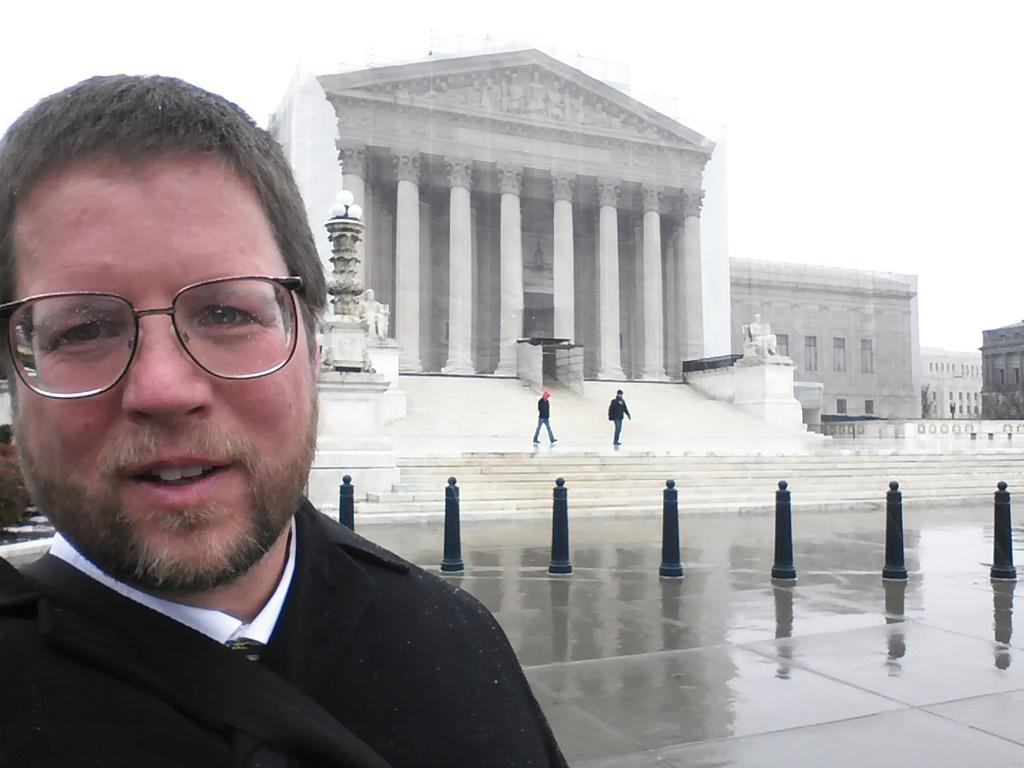What is the person in the image doing? The person is standing on the road. What can be seen on the road in the image? Barrier poles are present in the image. Where are the other persons located in the image? They are standing on a staircase. What type of lighting is visible in the image? Street lights are visible in the image. What type of artwork is present in the image? There are statues in the image. What type of structures are visible in the image? Buildings are present in the image. What part of the natural environment is visible in the image? The sky is visible in the image. Can you tell me how many books are being read by the squirrel in the image? There is no squirrel or book present in the image. What type of stranger is standing next to the person on the road in the image? There is no stranger present in the image; only the person standing on the road and the barrier poles are visible. 